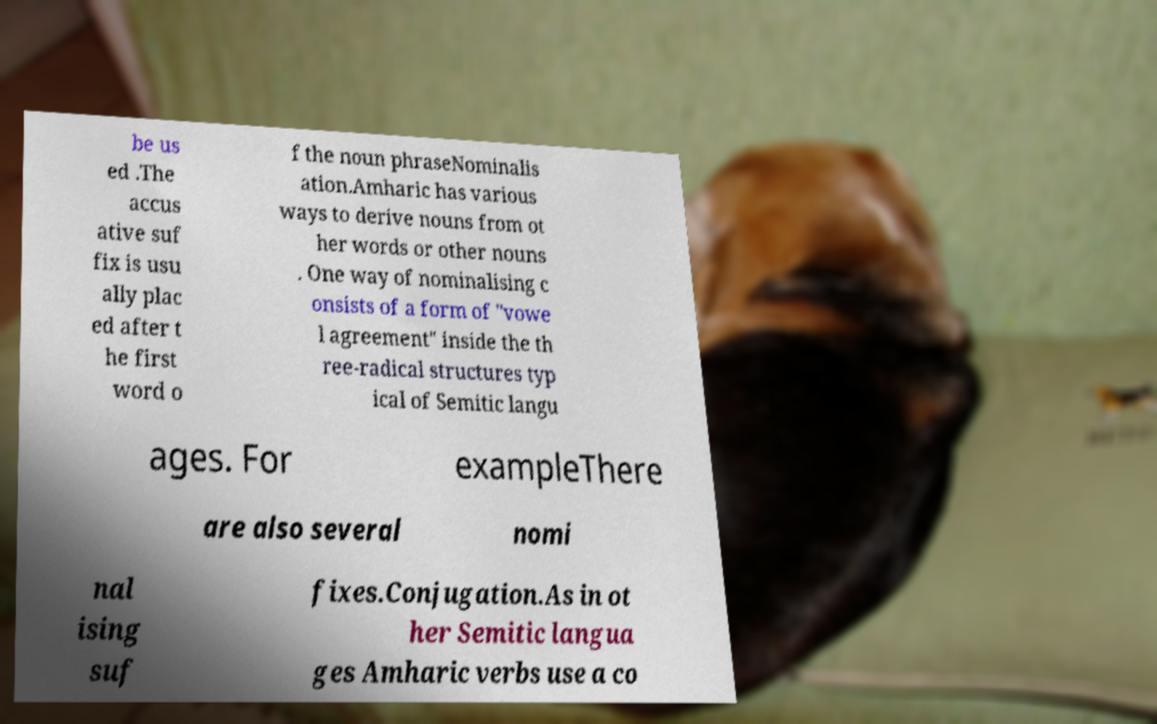What messages or text are displayed in this image? I need them in a readable, typed format. be us ed .The accus ative suf fix is usu ally plac ed after t he first word o f the noun phraseNominalis ation.Amharic has various ways to derive nouns from ot her words or other nouns . One way of nominalising c onsists of a form of "vowe l agreement" inside the th ree-radical structures typ ical of Semitic langu ages. For exampleThere are also several nomi nal ising suf fixes.Conjugation.As in ot her Semitic langua ges Amharic verbs use a co 